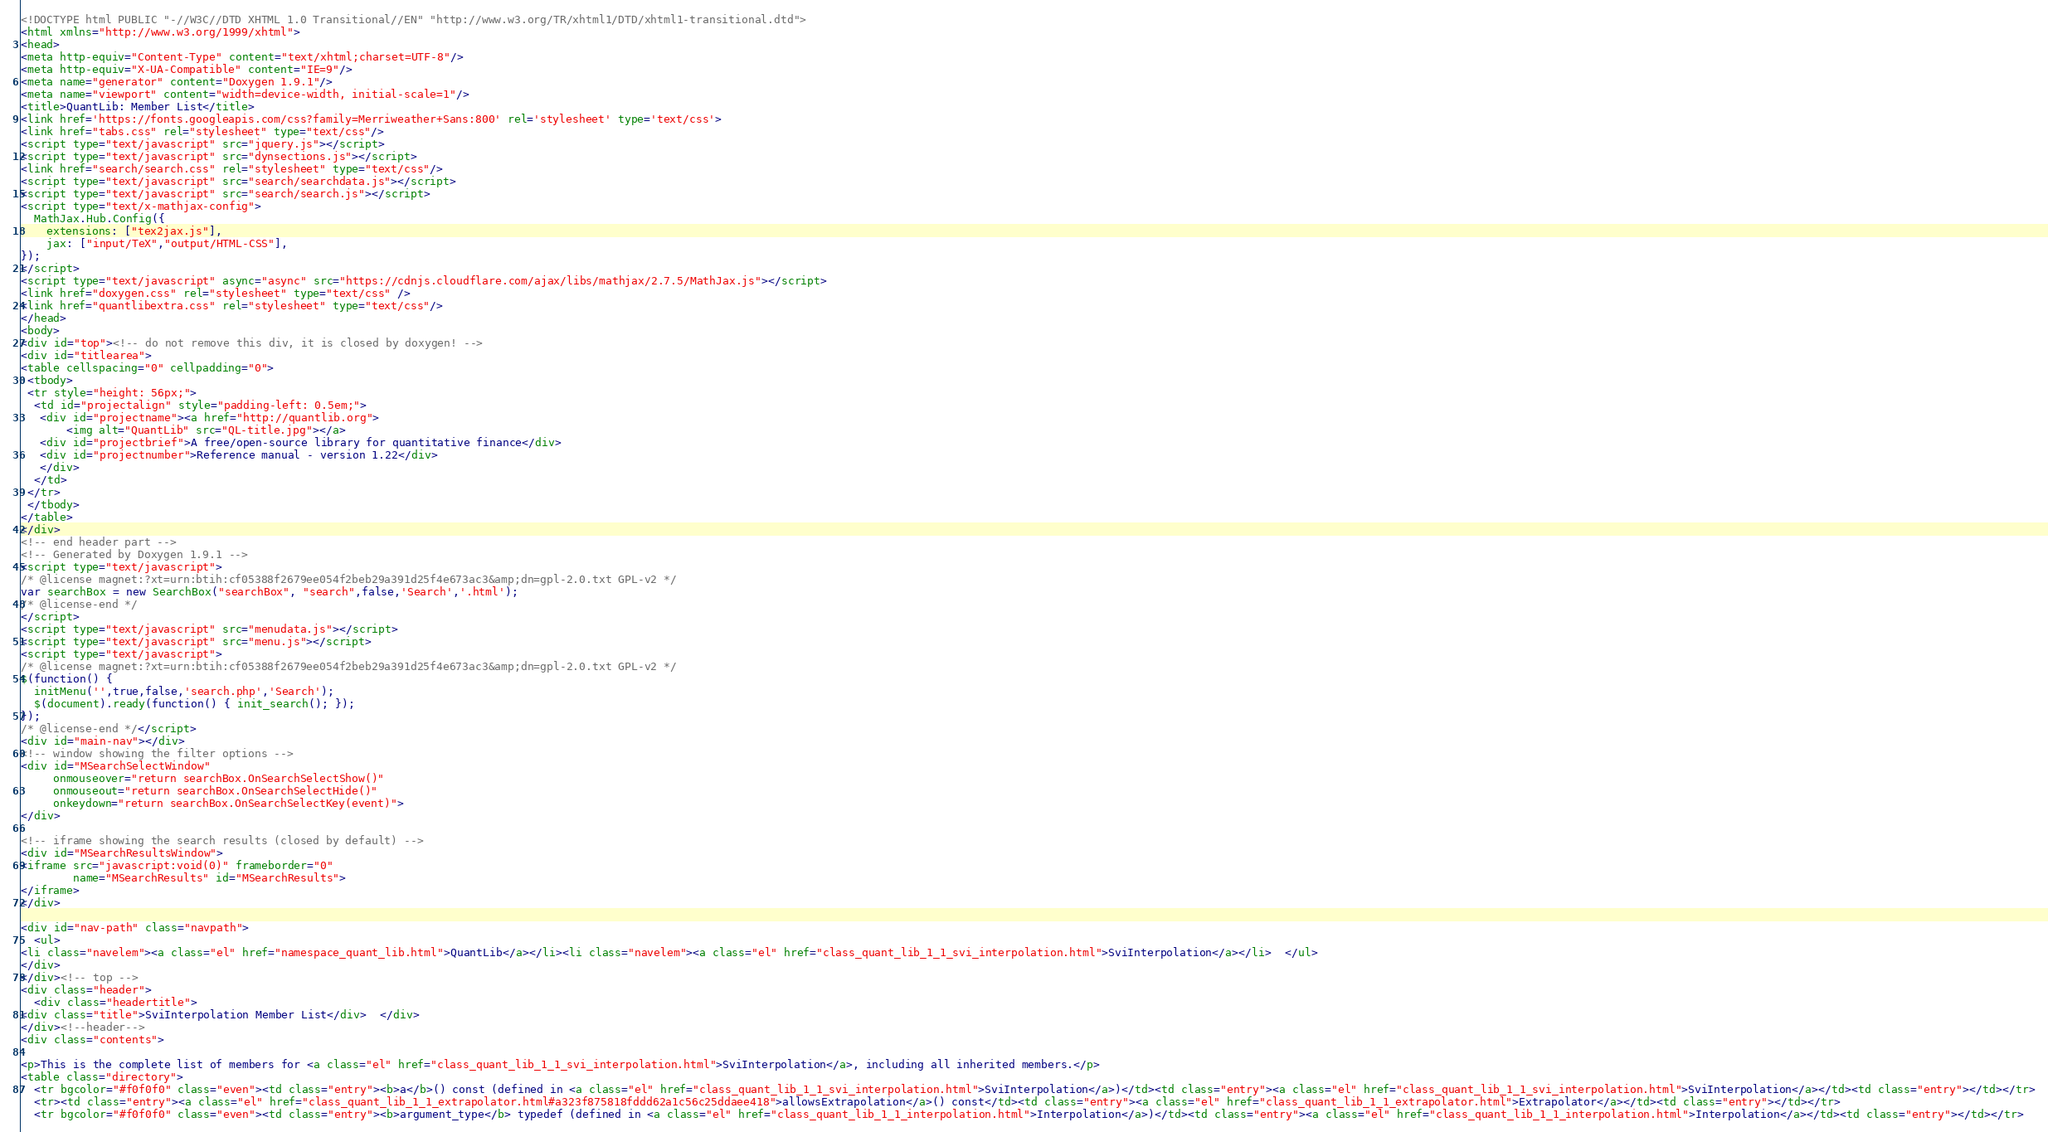<code> <loc_0><loc_0><loc_500><loc_500><_HTML_><!DOCTYPE html PUBLIC "-//W3C//DTD XHTML 1.0 Transitional//EN" "http://www.w3.org/TR/xhtml1/DTD/xhtml1-transitional.dtd">
<html xmlns="http://www.w3.org/1999/xhtml">
<head>
<meta http-equiv="Content-Type" content="text/xhtml;charset=UTF-8"/>
<meta http-equiv="X-UA-Compatible" content="IE=9"/>
<meta name="generator" content="Doxygen 1.9.1"/>
<meta name="viewport" content="width=device-width, initial-scale=1"/>
<title>QuantLib: Member List</title>
<link href='https://fonts.googleapis.com/css?family=Merriweather+Sans:800' rel='stylesheet' type='text/css'>
<link href="tabs.css" rel="stylesheet" type="text/css"/>
<script type="text/javascript" src="jquery.js"></script>
<script type="text/javascript" src="dynsections.js"></script>
<link href="search/search.css" rel="stylesheet" type="text/css"/>
<script type="text/javascript" src="search/searchdata.js"></script>
<script type="text/javascript" src="search/search.js"></script>
<script type="text/x-mathjax-config">
  MathJax.Hub.Config({
    extensions: ["tex2jax.js"],
    jax: ["input/TeX","output/HTML-CSS"],
});
</script>
<script type="text/javascript" async="async" src="https://cdnjs.cloudflare.com/ajax/libs/mathjax/2.7.5/MathJax.js"></script>
<link href="doxygen.css" rel="stylesheet" type="text/css" />
<link href="quantlibextra.css" rel="stylesheet" type="text/css"/>
</head>
<body>
<div id="top"><!-- do not remove this div, it is closed by doxygen! -->
<div id="titlearea">
<table cellspacing="0" cellpadding="0">
 <tbody>
 <tr style="height: 56px;">
  <td id="projectalign" style="padding-left: 0.5em;">
   <div id="projectname"><a href="http://quantlib.org">
       <img alt="QuantLib" src="QL-title.jpg"></a>
   <div id="projectbrief">A free/open-source library for quantitative finance</div>
   <div id="projectnumber">Reference manual - version 1.22</div>
   </div>
  </td>
 </tr>
 </tbody>
</table>
</div>
<!-- end header part -->
<!-- Generated by Doxygen 1.9.1 -->
<script type="text/javascript">
/* @license magnet:?xt=urn:btih:cf05388f2679ee054f2beb29a391d25f4e673ac3&amp;dn=gpl-2.0.txt GPL-v2 */
var searchBox = new SearchBox("searchBox", "search",false,'Search','.html');
/* @license-end */
</script>
<script type="text/javascript" src="menudata.js"></script>
<script type="text/javascript" src="menu.js"></script>
<script type="text/javascript">
/* @license magnet:?xt=urn:btih:cf05388f2679ee054f2beb29a391d25f4e673ac3&amp;dn=gpl-2.0.txt GPL-v2 */
$(function() {
  initMenu('',true,false,'search.php','Search');
  $(document).ready(function() { init_search(); });
});
/* @license-end */</script>
<div id="main-nav"></div>
<!-- window showing the filter options -->
<div id="MSearchSelectWindow"
     onmouseover="return searchBox.OnSearchSelectShow()"
     onmouseout="return searchBox.OnSearchSelectHide()"
     onkeydown="return searchBox.OnSearchSelectKey(event)">
</div>

<!-- iframe showing the search results (closed by default) -->
<div id="MSearchResultsWindow">
<iframe src="javascript:void(0)" frameborder="0" 
        name="MSearchResults" id="MSearchResults">
</iframe>
</div>

<div id="nav-path" class="navpath">
  <ul>
<li class="navelem"><a class="el" href="namespace_quant_lib.html">QuantLib</a></li><li class="navelem"><a class="el" href="class_quant_lib_1_1_svi_interpolation.html">SviInterpolation</a></li>  </ul>
</div>
</div><!-- top -->
<div class="header">
  <div class="headertitle">
<div class="title">SviInterpolation Member List</div>  </div>
</div><!--header-->
<div class="contents">

<p>This is the complete list of members for <a class="el" href="class_quant_lib_1_1_svi_interpolation.html">SviInterpolation</a>, including all inherited members.</p>
<table class="directory">
  <tr bgcolor="#f0f0f0" class="even"><td class="entry"><b>a</b>() const (defined in <a class="el" href="class_quant_lib_1_1_svi_interpolation.html">SviInterpolation</a>)</td><td class="entry"><a class="el" href="class_quant_lib_1_1_svi_interpolation.html">SviInterpolation</a></td><td class="entry"></td></tr>
  <tr><td class="entry"><a class="el" href="class_quant_lib_1_1_extrapolator.html#a323f875818fddd62a1c56c25ddaee418">allowsExtrapolation</a>() const</td><td class="entry"><a class="el" href="class_quant_lib_1_1_extrapolator.html">Extrapolator</a></td><td class="entry"></td></tr>
  <tr bgcolor="#f0f0f0" class="even"><td class="entry"><b>argument_type</b> typedef (defined in <a class="el" href="class_quant_lib_1_1_interpolation.html">Interpolation</a>)</td><td class="entry"><a class="el" href="class_quant_lib_1_1_interpolation.html">Interpolation</a></td><td class="entry"></td></tr></code> 